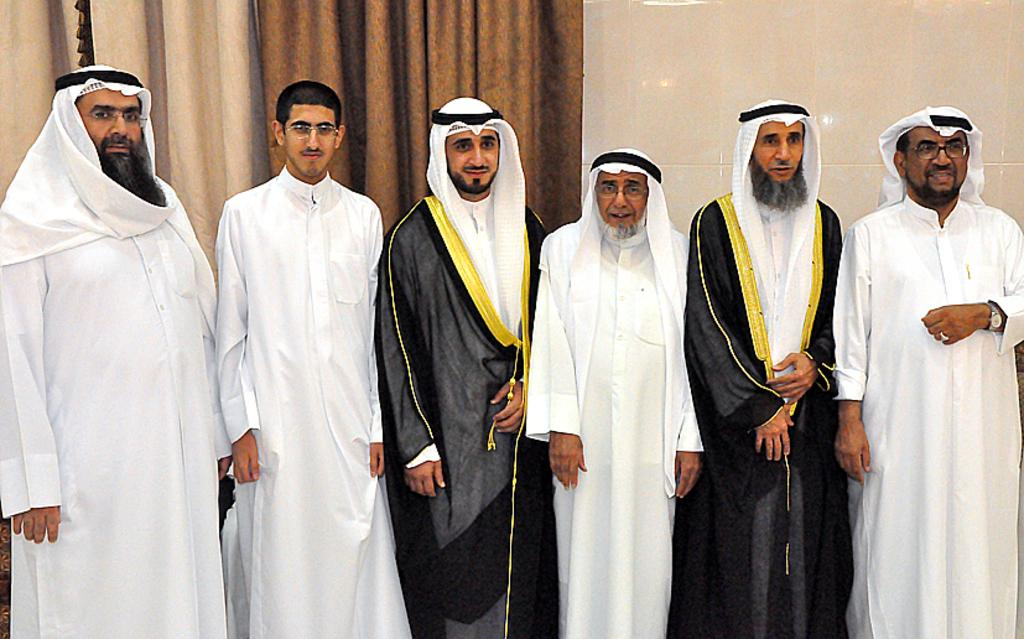How many people are in the image? There is a group of people in the image, but the exact number is not specified. What are the people in the image doing? The people are standing in the image. What can be seen in the background of the image? There is a wall and curtains visible in the background of the image. What type of sand can be seen on the floor in the image? There is no sand visible on the floor in the image. Is there a birthday celebration happening in the image? There is no indication of a birthday celebration in the image. 